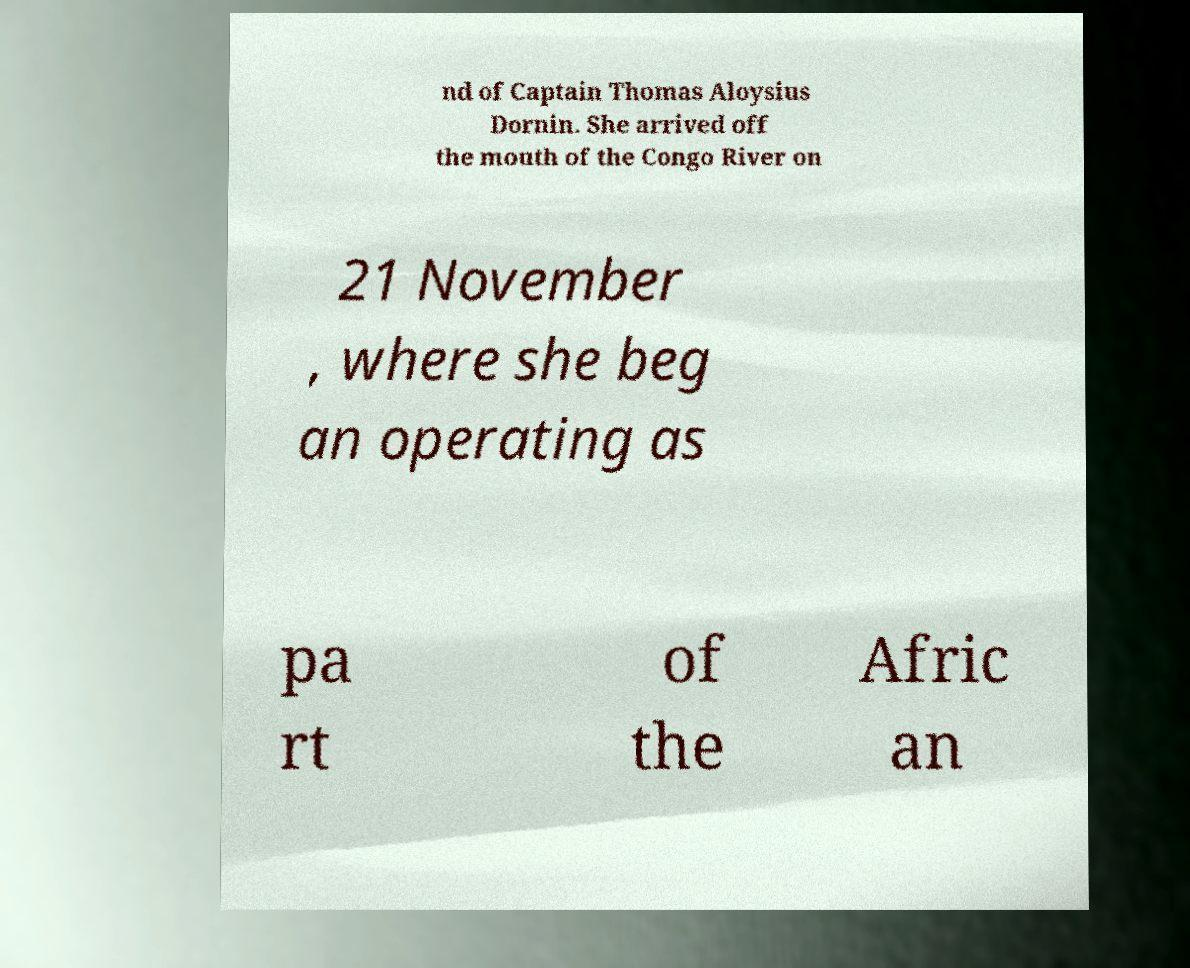Can you read and provide the text displayed in the image?This photo seems to have some interesting text. Can you extract and type it out for me? nd of Captain Thomas Aloysius Dornin. She arrived off the mouth of the Congo River on 21 November , where she beg an operating as pa rt of the Afric an 